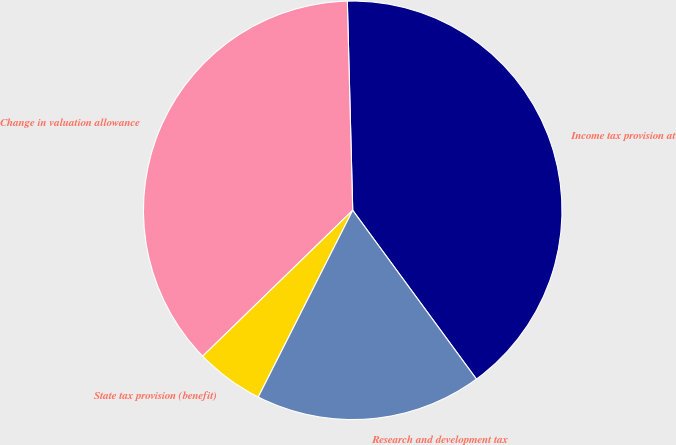Convert chart to OTSL. <chart><loc_0><loc_0><loc_500><loc_500><pie_chart><fcel>Income tax provision at<fcel>Change in valuation allowance<fcel>State tax provision (benefit)<fcel>Research and development tax<nl><fcel>40.35%<fcel>36.87%<fcel>5.27%<fcel>17.52%<nl></chart> 